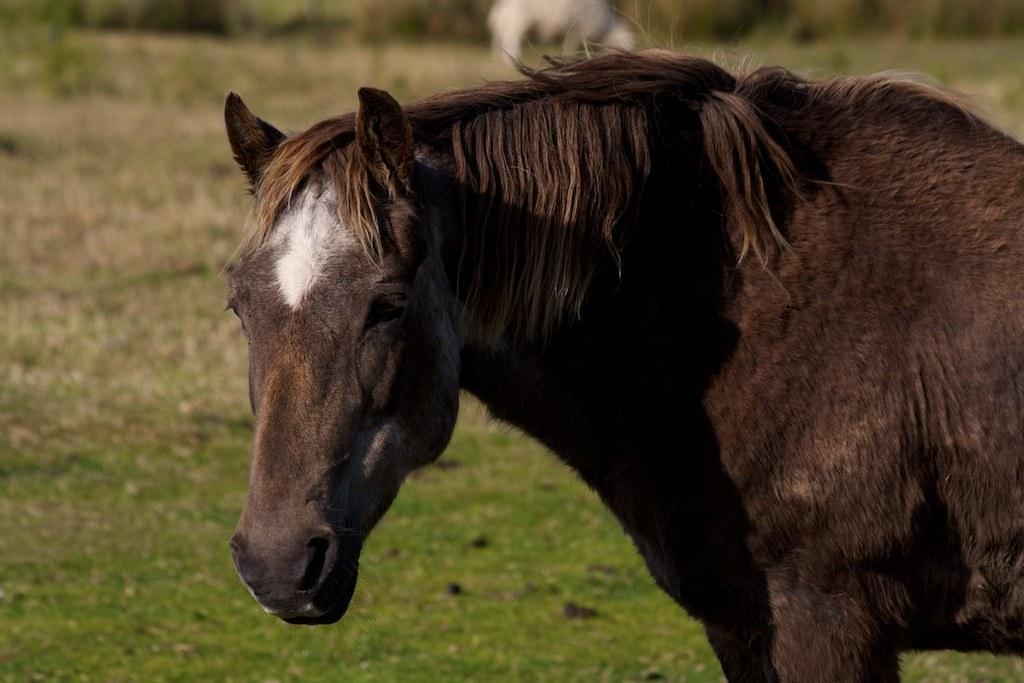In one or two sentences, can you explain what this image depicts? Here in this picture we can see a horse present on the field, which is covered with grass all over there and in the far we can see plants and other animals also present over there. 